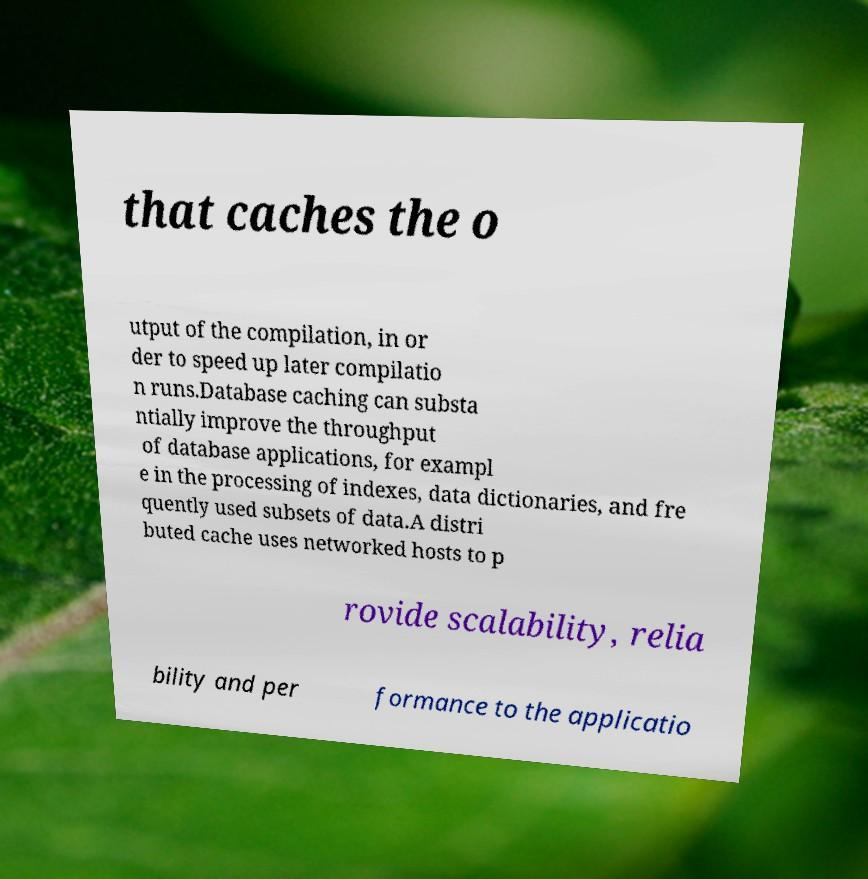There's text embedded in this image that I need extracted. Can you transcribe it verbatim? that caches the o utput of the compilation, in or der to speed up later compilatio n runs.Database caching can substa ntially improve the throughput of database applications, for exampl e in the processing of indexes, data dictionaries, and fre quently used subsets of data.A distri buted cache uses networked hosts to p rovide scalability, relia bility and per formance to the applicatio 